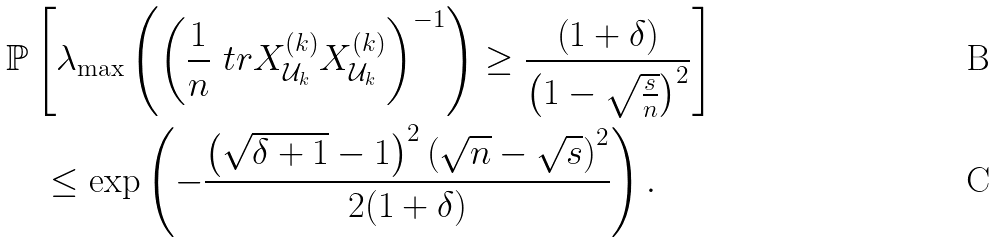<formula> <loc_0><loc_0><loc_500><loc_500>& \mathbb { P } \left [ \lambda _ { \max } \left ( \left ( \frac { 1 } { n } \ t r { X ^ { ( k ) } _ { \mathcal { U } _ { k } } } { X ^ { ( k ) } _ { \mathcal { U } _ { k } } } \right ) ^ { - 1 } \right ) \geq \frac { \left ( 1 + \delta \right ) } { \left ( 1 - \sqrt { \frac { s } { n } } \right ) ^ { 2 } } \right ] \\ & \quad \leq \exp \left ( - \frac { \left ( \sqrt { \delta + 1 } - 1 \right ) ^ { 2 } \left ( \sqrt { n } - \sqrt { s } \right ) ^ { 2 } } { 2 ( 1 + \delta ) } \right ) .</formula> 